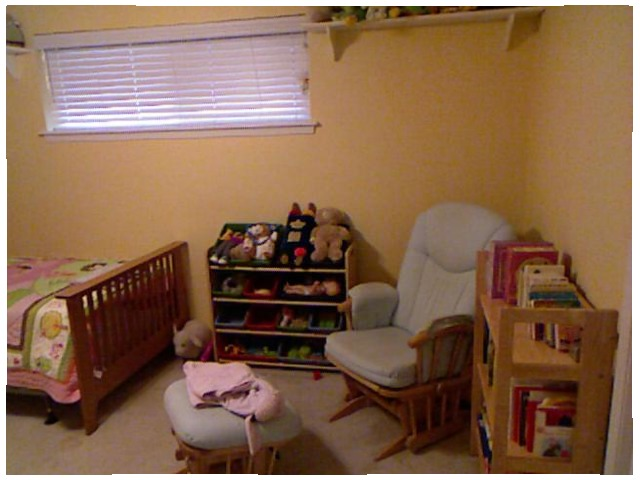<image>
Can you confirm if the shelf is behind the chair? No. The shelf is not behind the chair. From this viewpoint, the shelf appears to be positioned elsewhere in the scene. 